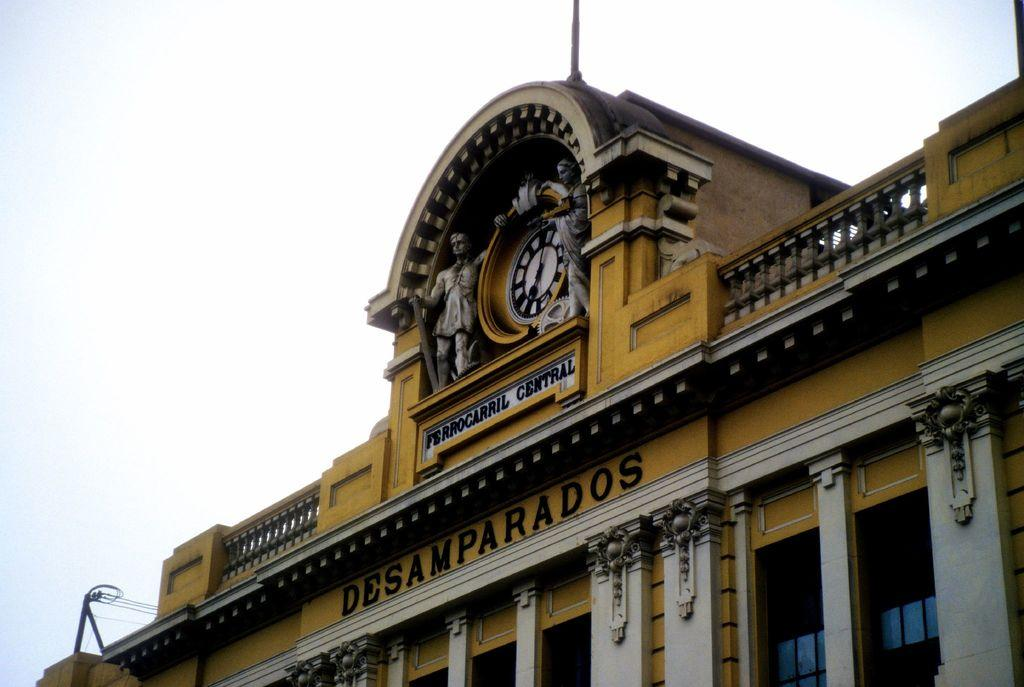<image>
Present a compact description of the photo's key features. The Central Railway building of Desamparados is a burnt yellow color and has the name mounted on it, in another language. 